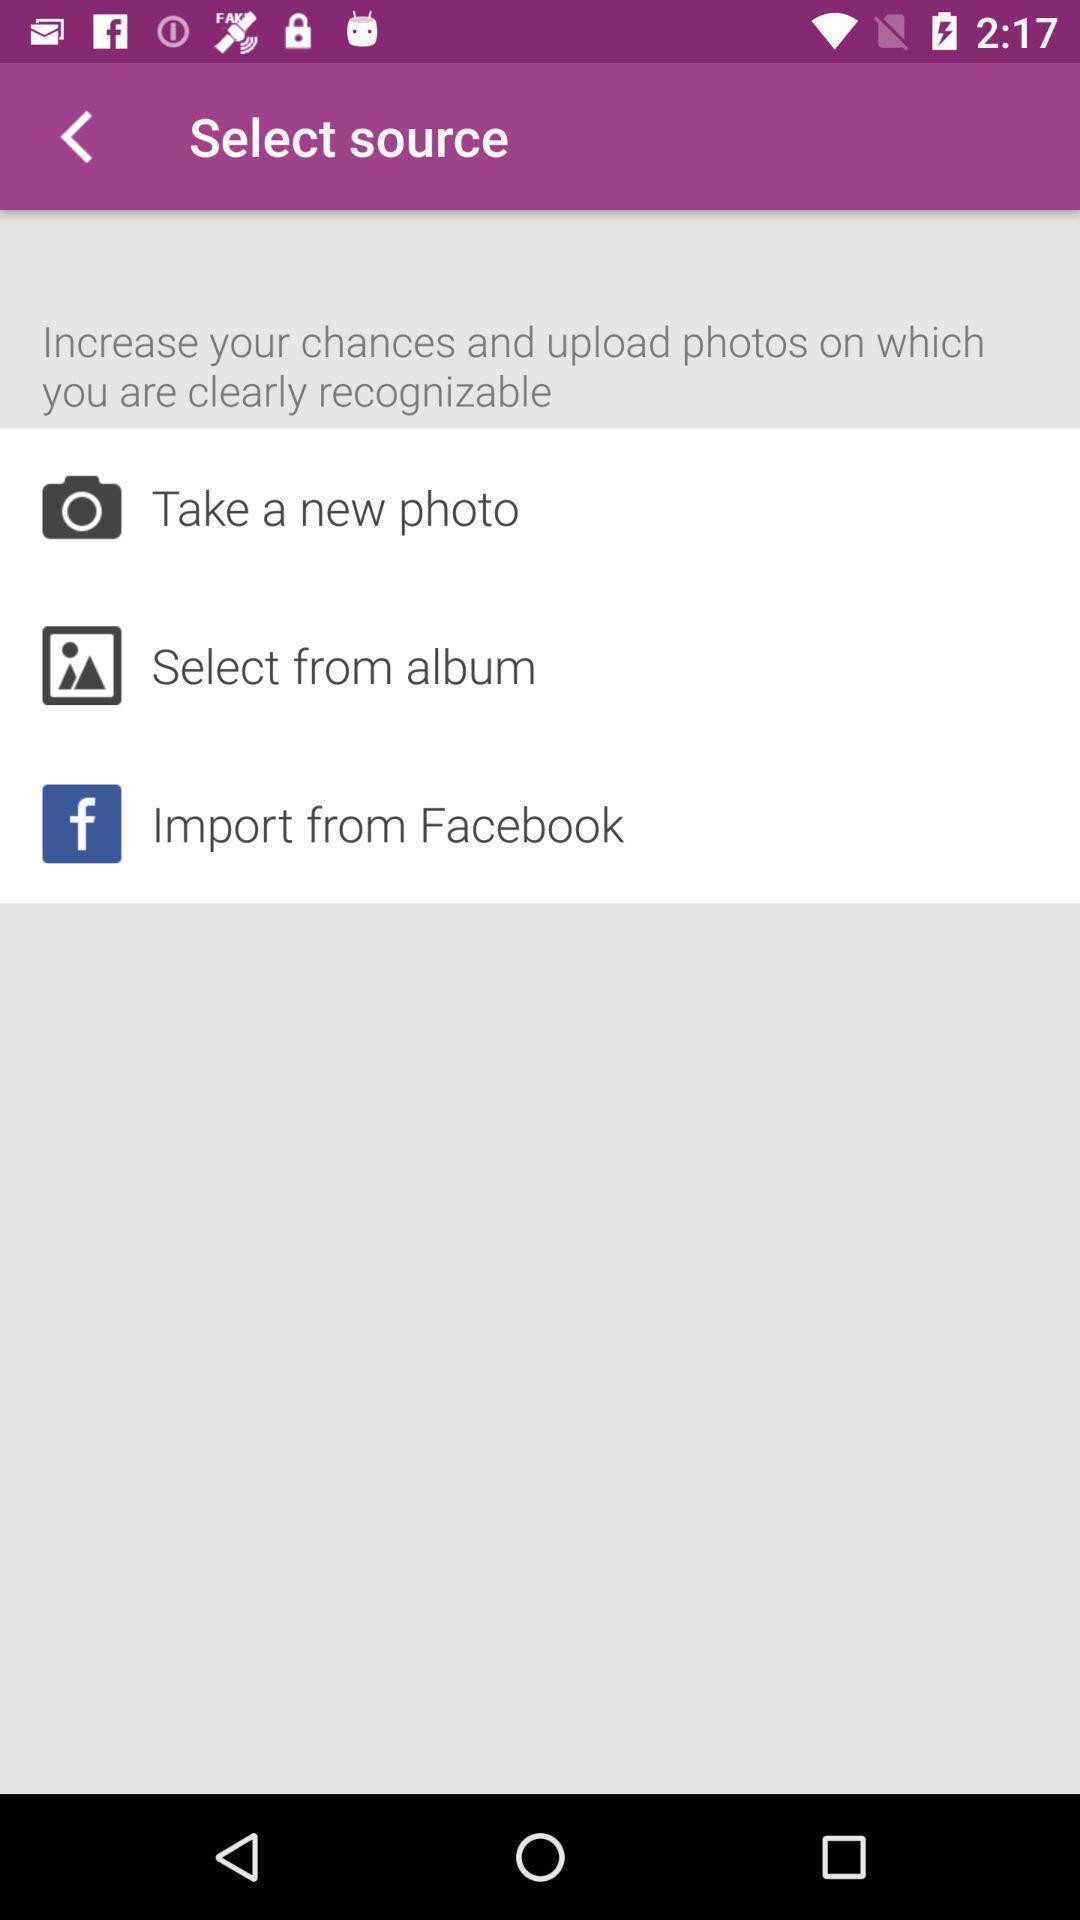Explain the elements present in this screenshot. Page for selecting a source for upload of a photo. 